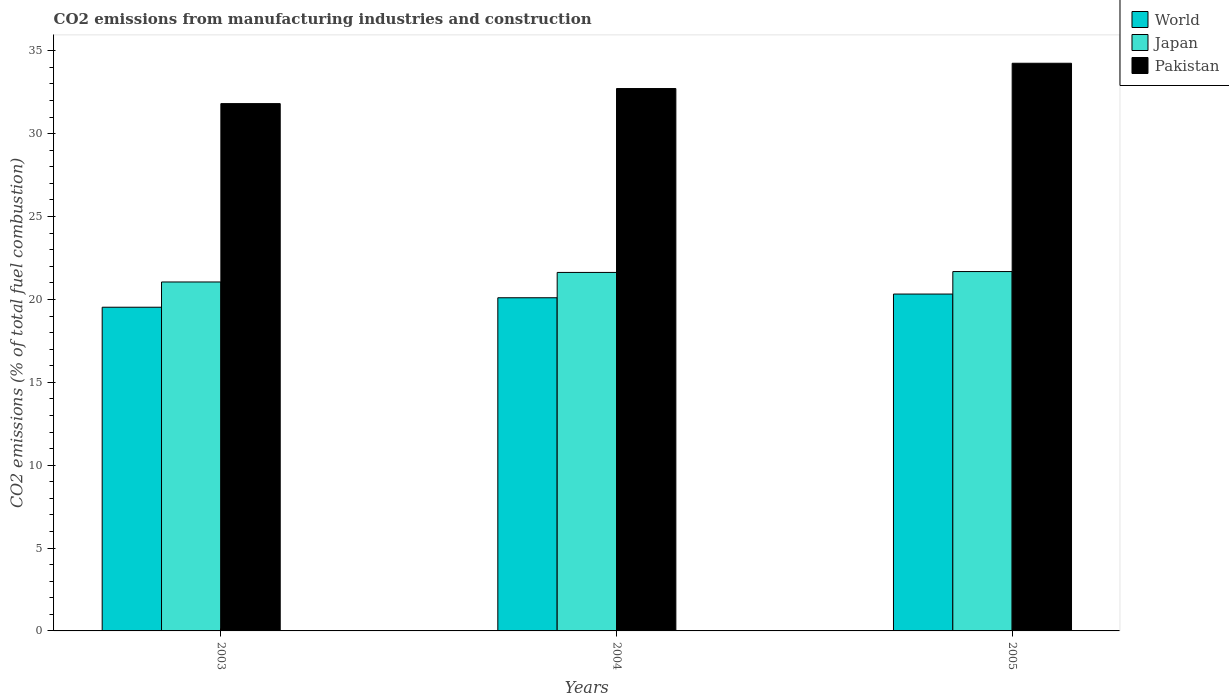Are the number of bars per tick equal to the number of legend labels?
Provide a short and direct response. Yes. How many bars are there on the 2nd tick from the left?
Offer a very short reply. 3. What is the label of the 2nd group of bars from the left?
Ensure brevity in your answer.  2004. In how many cases, is the number of bars for a given year not equal to the number of legend labels?
Your response must be concise. 0. What is the amount of CO2 emitted in Japan in 2003?
Ensure brevity in your answer.  21.05. Across all years, what is the maximum amount of CO2 emitted in Pakistan?
Your answer should be compact. 34.25. Across all years, what is the minimum amount of CO2 emitted in World?
Your answer should be compact. 19.53. In which year was the amount of CO2 emitted in World minimum?
Your response must be concise. 2003. What is the total amount of CO2 emitted in World in the graph?
Ensure brevity in your answer.  59.95. What is the difference between the amount of CO2 emitted in Pakistan in 2003 and that in 2004?
Keep it short and to the point. -0.91. What is the difference between the amount of CO2 emitted in Japan in 2003 and the amount of CO2 emitted in Pakistan in 2005?
Keep it short and to the point. -13.2. What is the average amount of CO2 emitted in Japan per year?
Your answer should be very brief. 21.45. In the year 2005, what is the difference between the amount of CO2 emitted in Pakistan and amount of CO2 emitted in Japan?
Your response must be concise. 12.57. What is the ratio of the amount of CO2 emitted in World in 2003 to that in 2005?
Make the answer very short. 0.96. Is the amount of CO2 emitted in World in 2004 less than that in 2005?
Provide a short and direct response. Yes. What is the difference between the highest and the second highest amount of CO2 emitted in World?
Offer a very short reply. 0.22. What is the difference between the highest and the lowest amount of CO2 emitted in World?
Your answer should be very brief. 0.79. In how many years, is the amount of CO2 emitted in World greater than the average amount of CO2 emitted in World taken over all years?
Keep it short and to the point. 2. What does the 2nd bar from the left in 2005 represents?
Your response must be concise. Japan. What does the 1st bar from the right in 2003 represents?
Provide a succinct answer. Pakistan. How many bars are there?
Offer a very short reply. 9. Are all the bars in the graph horizontal?
Keep it short and to the point. No. How many years are there in the graph?
Your answer should be very brief. 3. What is the difference between two consecutive major ticks on the Y-axis?
Provide a succinct answer. 5. Are the values on the major ticks of Y-axis written in scientific E-notation?
Make the answer very short. No. Does the graph contain any zero values?
Make the answer very short. No. What is the title of the graph?
Ensure brevity in your answer.  CO2 emissions from manufacturing industries and construction. What is the label or title of the Y-axis?
Give a very brief answer. CO2 emissions (% of total fuel combustion). What is the CO2 emissions (% of total fuel combustion) in World in 2003?
Offer a terse response. 19.53. What is the CO2 emissions (% of total fuel combustion) in Japan in 2003?
Ensure brevity in your answer.  21.05. What is the CO2 emissions (% of total fuel combustion) in Pakistan in 2003?
Provide a short and direct response. 31.81. What is the CO2 emissions (% of total fuel combustion) of World in 2004?
Offer a terse response. 20.1. What is the CO2 emissions (% of total fuel combustion) of Japan in 2004?
Provide a short and direct response. 21.63. What is the CO2 emissions (% of total fuel combustion) in Pakistan in 2004?
Your response must be concise. 32.72. What is the CO2 emissions (% of total fuel combustion) in World in 2005?
Your answer should be very brief. 20.32. What is the CO2 emissions (% of total fuel combustion) in Japan in 2005?
Your answer should be very brief. 21.68. What is the CO2 emissions (% of total fuel combustion) in Pakistan in 2005?
Provide a succinct answer. 34.25. Across all years, what is the maximum CO2 emissions (% of total fuel combustion) in World?
Your answer should be compact. 20.32. Across all years, what is the maximum CO2 emissions (% of total fuel combustion) of Japan?
Make the answer very short. 21.68. Across all years, what is the maximum CO2 emissions (% of total fuel combustion) in Pakistan?
Your answer should be compact. 34.25. Across all years, what is the minimum CO2 emissions (% of total fuel combustion) in World?
Your answer should be very brief. 19.53. Across all years, what is the minimum CO2 emissions (% of total fuel combustion) of Japan?
Keep it short and to the point. 21.05. Across all years, what is the minimum CO2 emissions (% of total fuel combustion) in Pakistan?
Offer a terse response. 31.81. What is the total CO2 emissions (% of total fuel combustion) in World in the graph?
Provide a succinct answer. 59.95. What is the total CO2 emissions (% of total fuel combustion) in Japan in the graph?
Provide a short and direct response. 64.36. What is the total CO2 emissions (% of total fuel combustion) in Pakistan in the graph?
Keep it short and to the point. 98.79. What is the difference between the CO2 emissions (% of total fuel combustion) in World in 2003 and that in 2004?
Your answer should be compact. -0.57. What is the difference between the CO2 emissions (% of total fuel combustion) in Japan in 2003 and that in 2004?
Make the answer very short. -0.58. What is the difference between the CO2 emissions (% of total fuel combustion) of Pakistan in 2003 and that in 2004?
Ensure brevity in your answer.  -0.91. What is the difference between the CO2 emissions (% of total fuel combustion) of World in 2003 and that in 2005?
Provide a short and direct response. -0.79. What is the difference between the CO2 emissions (% of total fuel combustion) of Japan in 2003 and that in 2005?
Provide a short and direct response. -0.63. What is the difference between the CO2 emissions (% of total fuel combustion) in Pakistan in 2003 and that in 2005?
Your response must be concise. -2.43. What is the difference between the CO2 emissions (% of total fuel combustion) in World in 2004 and that in 2005?
Your answer should be compact. -0.22. What is the difference between the CO2 emissions (% of total fuel combustion) of Japan in 2004 and that in 2005?
Provide a succinct answer. -0.05. What is the difference between the CO2 emissions (% of total fuel combustion) in Pakistan in 2004 and that in 2005?
Your answer should be compact. -1.53. What is the difference between the CO2 emissions (% of total fuel combustion) in World in 2003 and the CO2 emissions (% of total fuel combustion) in Japan in 2004?
Your response must be concise. -2.1. What is the difference between the CO2 emissions (% of total fuel combustion) in World in 2003 and the CO2 emissions (% of total fuel combustion) in Pakistan in 2004?
Offer a terse response. -13.19. What is the difference between the CO2 emissions (% of total fuel combustion) in Japan in 2003 and the CO2 emissions (% of total fuel combustion) in Pakistan in 2004?
Your response must be concise. -11.67. What is the difference between the CO2 emissions (% of total fuel combustion) of World in 2003 and the CO2 emissions (% of total fuel combustion) of Japan in 2005?
Provide a succinct answer. -2.15. What is the difference between the CO2 emissions (% of total fuel combustion) in World in 2003 and the CO2 emissions (% of total fuel combustion) in Pakistan in 2005?
Make the answer very short. -14.72. What is the difference between the CO2 emissions (% of total fuel combustion) of Japan in 2003 and the CO2 emissions (% of total fuel combustion) of Pakistan in 2005?
Your answer should be compact. -13.2. What is the difference between the CO2 emissions (% of total fuel combustion) in World in 2004 and the CO2 emissions (% of total fuel combustion) in Japan in 2005?
Provide a succinct answer. -1.58. What is the difference between the CO2 emissions (% of total fuel combustion) of World in 2004 and the CO2 emissions (% of total fuel combustion) of Pakistan in 2005?
Provide a short and direct response. -14.15. What is the difference between the CO2 emissions (% of total fuel combustion) in Japan in 2004 and the CO2 emissions (% of total fuel combustion) in Pakistan in 2005?
Make the answer very short. -12.62. What is the average CO2 emissions (% of total fuel combustion) in World per year?
Keep it short and to the point. 19.98. What is the average CO2 emissions (% of total fuel combustion) of Japan per year?
Make the answer very short. 21.45. What is the average CO2 emissions (% of total fuel combustion) of Pakistan per year?
Provide a succinct answer. 32.93. In the year 2003, what is the difference between the CO2 emissions (% of total fuel combustion) in World and CO2 emissions (% of total fuel combustion) in Japan?
Offer a very short reply. -1.52. In the year 2003, what is the difference between the CO2 emissions (% of total fuel combustion) of World and CO2 emissions (% of total fuel combustion) of Pakistan?
Offer a terse response. -12.28. In the year 2003, what is the difference between the CO2 emissions (% of total fuel combustion) of Japan and CO2 emissions (% of total fuel combustion) of Pakistan?
Provide a succinct answer. -10.76. In the year 2004, what is the difference between the CO2 emissions (% of total fuel combustion) in World and CO2 emissions (% of total fuel combustion) in Japan?
Offer a very short reply. -1.53. In the year 2004, what is the difference between the CO2 emissions (% of total fuel combustion) of World and CO2 emissions (% of total fuel combustion) of Pakistan?
Your response must be concise. -12.62. In the year 2004, what is the difference between the CO2 emissions (% of total fuel combustion) in Japan and CO2 emissions (% of total fuel combustion) in Pakistan?
Provide a short and direct response. -11.09. In the year 2005, what is the difference between the CO2 emissions (% of total fuel combustion) of World and CO2 emissions (% of total fuel combustion) of Japan?
Provide a short and direct response. -1.36. In the year 2005, what is the difference between the CO2 emissions (% of total fuel combustion) of World and CO2 emissions (% of total fuel combustion) of Pakistan?
Make the answer very short. -13.92. In the year 2005, what is the difference between the CO2 emissions (% of total fuel combustion) of Japan and CO2 emissions (% of total fuel combustion) of Pakistan?
Give a very brief answer. -12.57. What is the ratio of the CO2 emissions (% of total fuel combustion) of World in 2003 to that in 2004?
Your answer should be compact. 0.97. What is the ratio of the CO2 emissions (% of total fuel combustion) in Japan in 2003 to that in 2004?
Offer a terse response. 0.97. What is the ratio of the CO2 emissions (% of total fuel combustion) of Pakistan in 2003 to that in 2004?
Provide a succinct answer. 0.97. What is the ratio of the CO2 emissions (% of total fuel combustion) of World in 2003 to that in 2005?
Your answer should be very brief. 0.96. What is the ratio of the CO2 emissions (% of total fuel combustion) in Japan in 2003 to that in 2005?
Your answer should be very brief. 0.97. What is the ratio of the CO2 emissions (% of total fuel combustion) of Pakistan in 2003 to that in 2005?
Offer a very short reply. 0.93. What is the ratio of the CO2 emissions (% of total fuel combustion) of Pakistan in 2004 to that in 2005?
Offer a very short reply. 0.96. What is the difference between the highest and the second highest CO2 emissions (% of total fuel combustion) in World?
Ensure brevity in your answer.  0.22. What is the difference between the highest and the second highest CO2 emissions (% of total fuel combustion) of Japan?
Keep it short and to the point. 0.05. What is the difference between the highest and the second highest CO2 emissions (% of total fuel combustion) in Pakistan?
Offer a very short reply. 1.53. What is the difference between the highest and the lowest CO2 emissions (% of total fuel combustion) in World?
Offer a very short reply. 0.79. What is the difference between the highest and the lowest CO2 emissions (% of total fuel combustion) in Japan?
Give a very brief answer. 0.63. What is the difference between the highest and the lowest CO2 emissions (% of total fuel combustion) in Pakistan?
Your answer should be very brief. 2.43. 